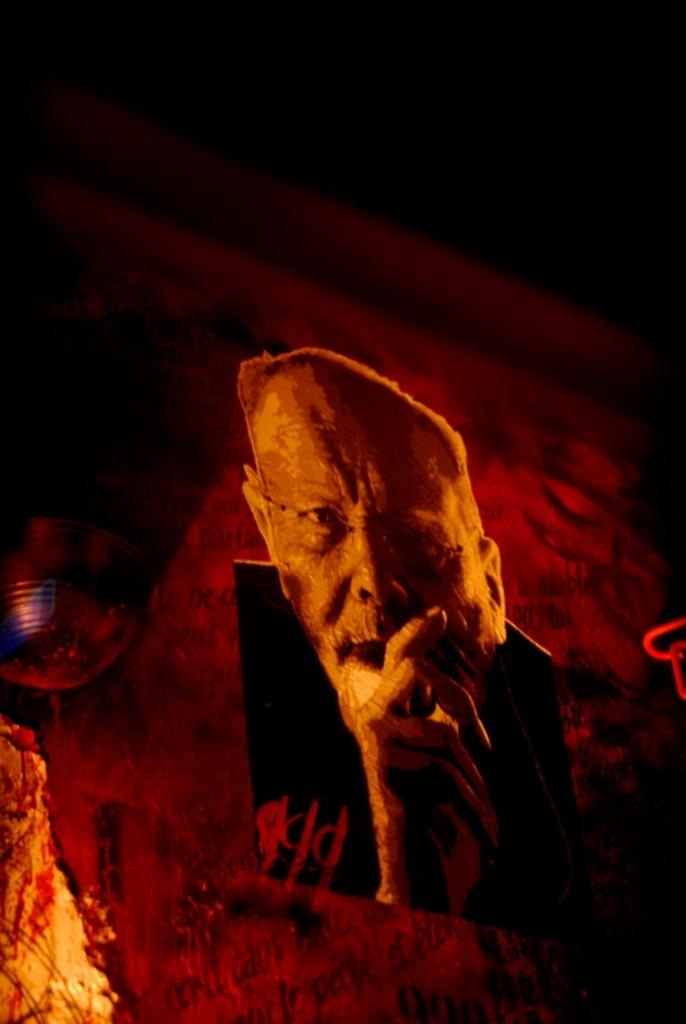What is the overall lighting condition in the image? The image is dark. What can be seen on the poster in the image? There is a poster of a person in the image. What object is present in the image that might be used for a specific purpose? There is a device in the image. What type of plough is being used by the person in the image? There is no plough present in the image; it only features a poster of a person and a device. How many trucks are visible in the image? There are no trucks visible in the image. 